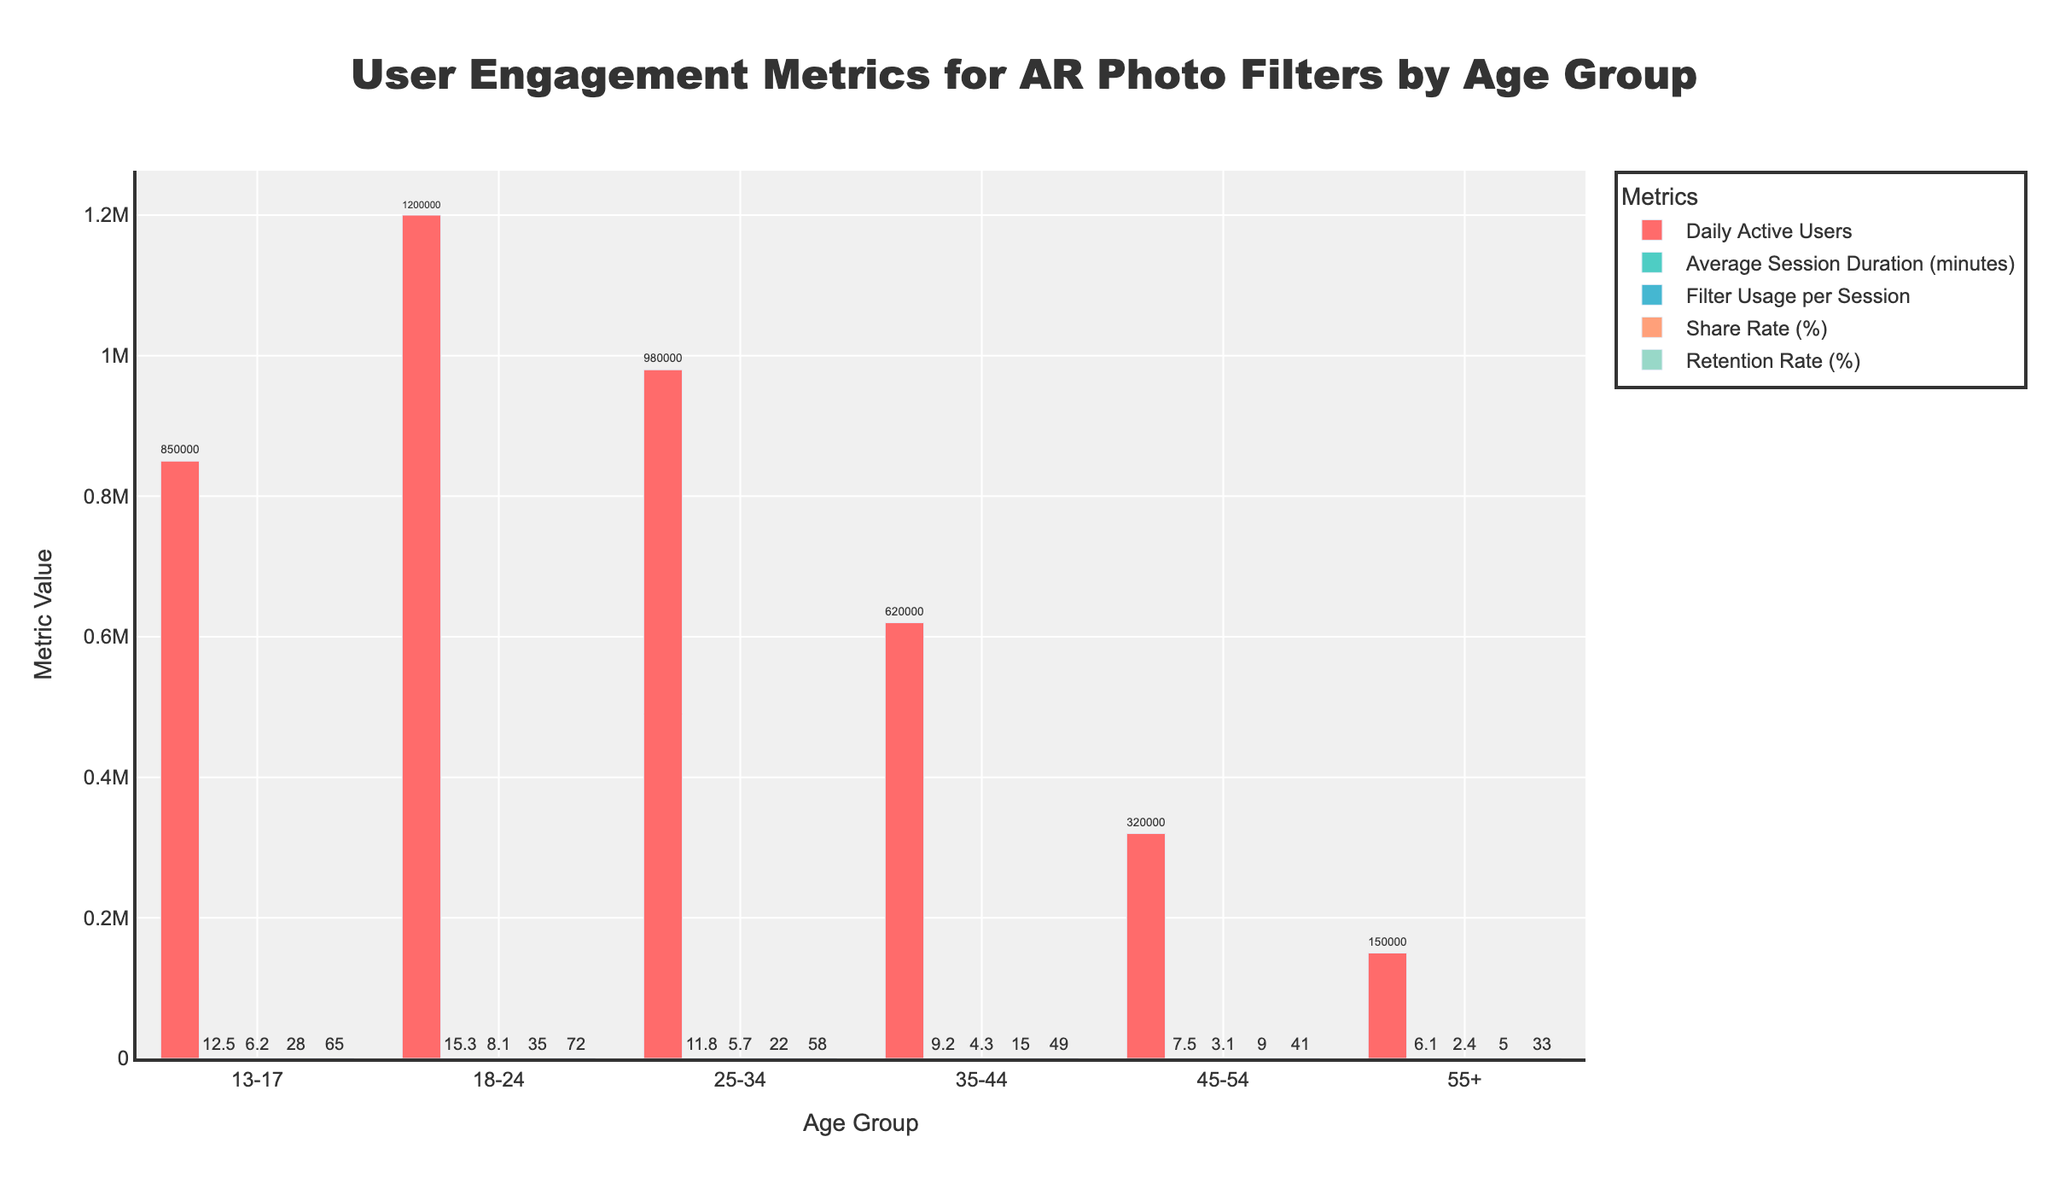Which age group has the highest Daily Active Users? The figure shows various age groups and their corresponding Daily Active Users. To find which age group has the highest number, look at the height of the bars for Daily Active Users. The tallest bar corresponds to the 18-24 age group.
Answer: 18-24 What is the difference in Daily Active Users between the 25-34 and 35-44 age groups? To determine the difference, look at the Daily Active Users values for the 25-34 and 35-44 age groups. The 25-34 group has 980,000 users, and the 35-44 group has 620,000 users. Subtract 620,000 from 980,000.
Answer: 360,000 Which age group has the highest Retention Rate (%)? To find the age group with the highest Retention Rate, observe the bars corresponding to the Retention Rate metric across all age groups. The 18-24 age group has the highest value.
Answer: 18-24 What is the average Share Rate (%) across all age groups? To find the average Share Rate, sum the Share Rate percentages for all age groups and divide by the number of age groups. The Share Rate percentages are 28, 35, 22, 15, 9, and 5. The sum is 114, and there are 6 age groups. Divide 114 by 6.
Answer: 19 How does the Filter Usage per Session for the 35-44 age group compare to the 45-54 age group? Compare the bar heights for the Filter Usage per Session metric for the 35-44 and 45-54 age groups. The 35-44 group has a value of 4.3, while the 45-54 group has 3.1. The 35-44 age group has a higher Filter Usage per Session.
Answer: 35-44 is higher Which metric shows the greatest difference between the 13-17 and 55+ age groups? Compare the differences for each metric between the 13-17 and 55+ age groups: Daily Active Users (700,000), Average Session Duration (6.4), Filter Usage per Session (3.8), Share Rate (23%), and Retention Rate (32%). The greatest difference is in Daily Active Users.
Answer: Daily Active Users What is the sum of Retention Rates (%) for the 18-24 and 35-44 age groups? Add the Retention Rates for the 18-24 (72%) and 35-44 (49%) age groups. The sum is 72 + 49.
Answer: 121 Which age group has the lowest Average Session Duration (minutes)? Look at the bars representing the Average Session Duration across all age groups. The shortest bar corresponds to the 55+ age group.
Answer: 55+ What is the combined number of Daily Active Users for the 13-17 and 18-24 age groups? Add the Daily Active Users for the 13-17 (850,000) and 18-24 (1,200,000) age groups. The combined total is 850,000 + 1,200,000.
Answer: 2,050,000 Between which age groups is the Share Rate (%) difference the smallest? Compare the differences in Share Rate percentages between each pair of age groups. The smallest difference is between the 35-44 (15%) and 45-54 (9%) age groups, with a difference of 6%.
Answer: 35-44 and 45-54 